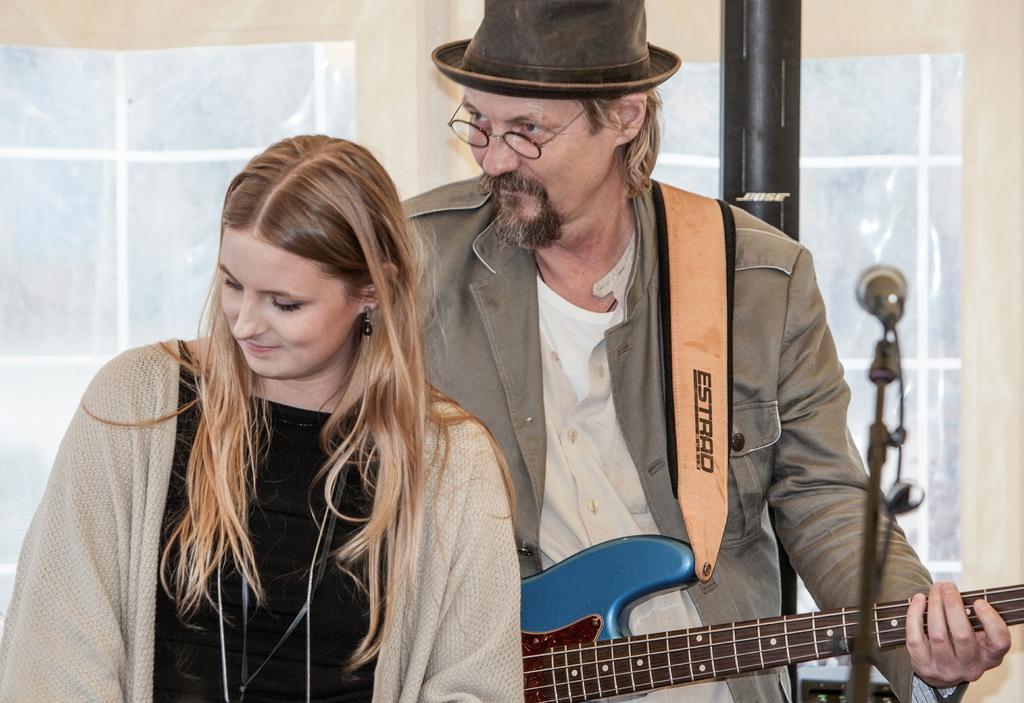Describe this image in one or two sentences. In this image I can see a woman and a man where he is holding a guitar and wearing a cap and specs. I can also see a mic in front of them. 